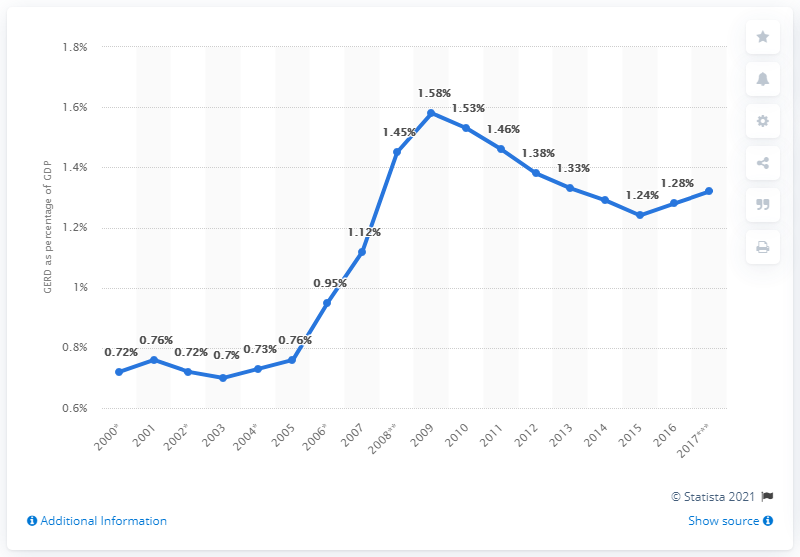Draw attention to some important aspects in this diagram. In 2009, the GERD (Gross External Resource Flow) to GDP (Gross Domestic Product) ratio was 1.58. This indicates that the flow of resources from external sources to Egypt's economy was 1.58 times greater than the size of its domestic economy. In 2017, Portugal's GDP was spent on research and development to the tune of 1.32%. 